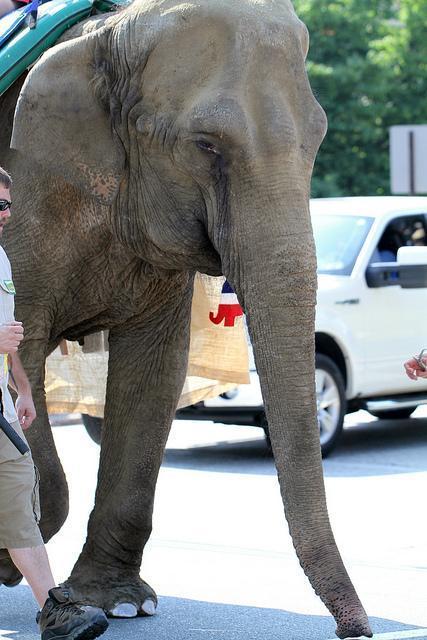How many cars are there?
Give a very brief answer. 1. 